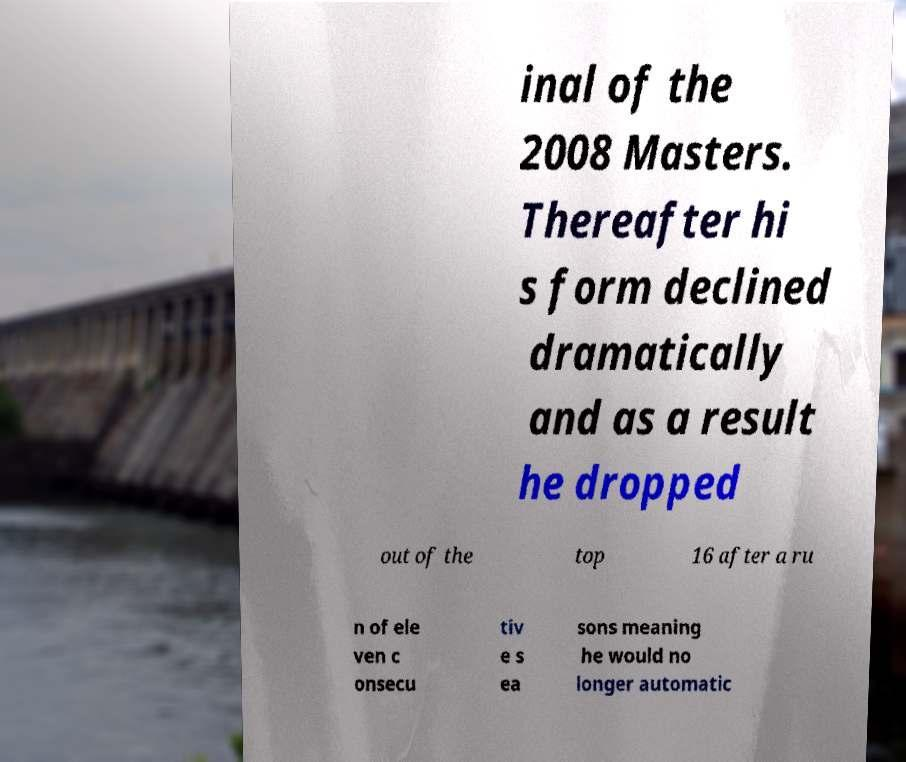Can you accurately transcribe the text from the provided image for me? inal of the 2008 Masters. Thereafter hi s form declined dramatically and as a result he dropped out of the top 16 after a ru n of ele ven c onsecu tiv e s ea sons meaning he would no longer automatic 